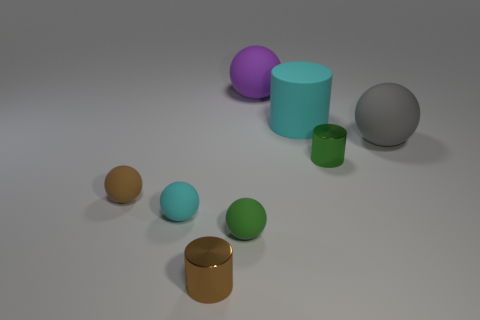The rubber cylinder is what color?
Offer a terse response. Cyan. There is another small shiny thing that is the same shape as the brown metallic object; what color is it?
Ensure brevity in your answer.  Green. How many large gray rubber things are the same shape as the purple rubber object?
Make the answer very short. 1. What number of things are green matte spheres or tiny brown objects behind the tiny brown cylinder?
Provide a short and direct response. 2. There is a matte thing that is behind the big gray matte sphere and in front of the big purple matte object; what size is it?
Give a very brief answer. Large. Are there any brown rubber objects behind the big purple thing?
Provide a short and direct response. No. Is there a green ball in front of the cyan matte thing that is left of the small brown metal object?
Your answer should be very brief. Yes. Are there the same number of purple matte objects on the right side of the large cyan rubber cylinder and spheres that are right of the small brown rubber object?
Provide a short and direct response. No. There is a cylinder that is made of the same material as the brown sphere; what is its color?
Your answer should be compact. Cyan. Are there any red cylinders made of the same material as the tiny brown sphere?
Provide a short and direct response. No. 